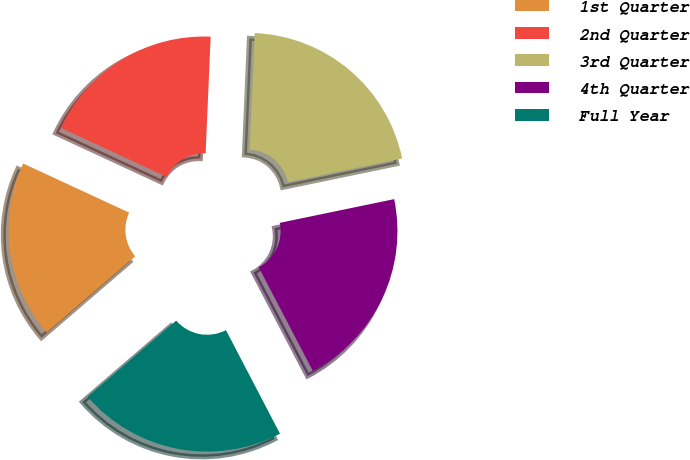<chart> <loc_0><loc_0><loc_500><loc_500><pie_chart><fcel>1st Quarter<fcel>2nd Quarter<fcel>3rd Quarter<fcel>4th Quarter<fcel>Full Year<nl><fcel>18.21%<fcel>18.78%<fcel>21.06%<fcel>20.6%<fcel>21.35%<nl></chart> 